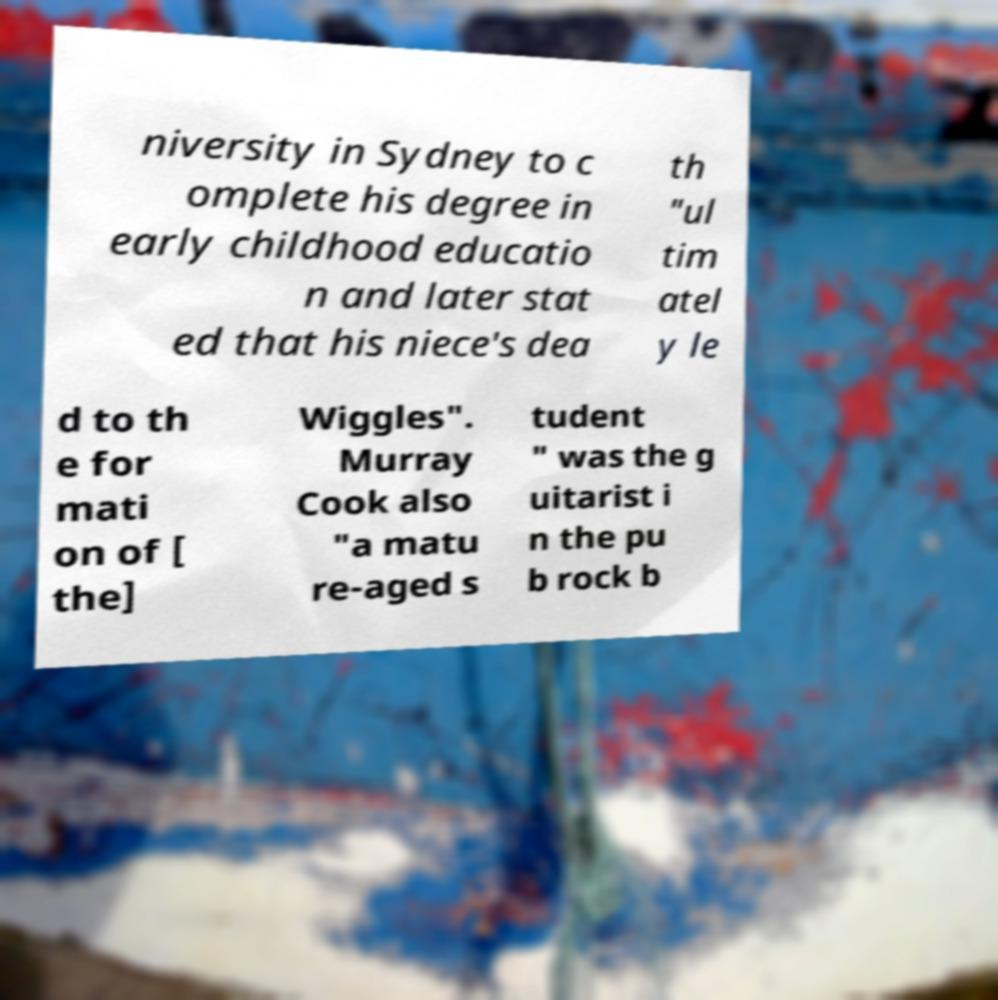Can you accurately transcribe the text from the provided image for me? niversity in Sydney to c omplete his degree in early childhood educatio n and later stat ed that his niece's dea th "ul tim atel y le d to th e for mati on of [ the] Wiggles". Murray Cook also "a matu re-aged s tudent " was the g uitarist i n the pu b rock b 